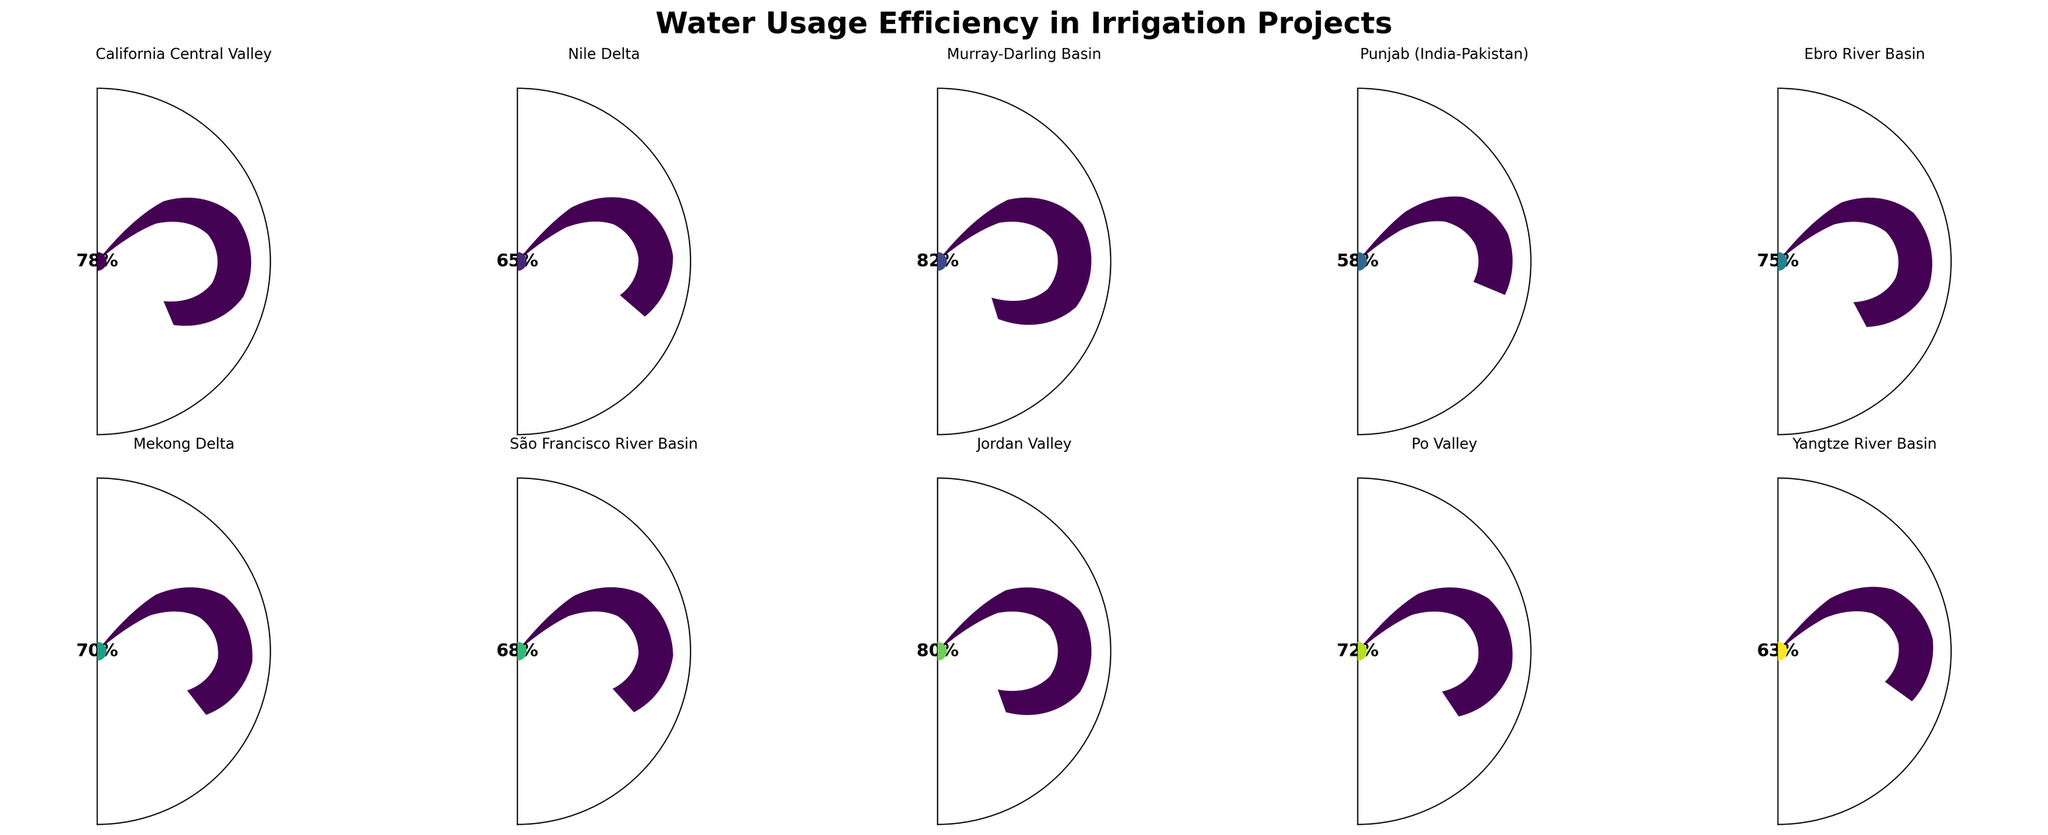Which region has the highest water usage efficiency? First, identify the gauge chart with the highest efficiency percentage. The Murray-Darling Basin has an efficiency of 82%, which is the highest among the regions listed.
Answer: Murray-Darling Basin Which region has the lowest water usage efficiency? Identify the gauge chart with the lowest efficiency percentage. Punjab (India-Pakistan) shows an efficiency of 58%, making it the lowest among the regions listed.
Answer: Punjab (India-Pakistan) What is the average water usage efficiency across all regions? Add up the water usage efficiencies for all regions (78 + 65 + 82 + 58 + 75 + 70 + 68 + 80 + 72 + 63 = 711) and divide by the number of regions (10) to get the average (711 / 10).
Answer: 71.1% Which regions have an efficiency greater than 75%? Identify the gauge charts with efficiency percentages greater than 75%. The regions are California Central Valley (78%), Murray-Darling Basin (82%), and Jordan Valley (80%).
Answer: California Central Valley, Murray-Darling Basin, Jordan Valley How many regions have an efficiency percentage between 60% and 70%? Count the number of gauge charts with efficiency percentages in the specified range. Examples include Nile Delta (65%), Mekong Delta (70%), and São Francisco River Basin (68%). The total is 3 regions.
Answer: 3 Is the water usage efficiency of Ebro River Basin greater than Yangtze River Basin? Compare the efficiency percentages of Ebro River Basin (75%) and Yangtze River Basin (63%) from the gauge charts. Since 75% is greater than 63%, the efficiency of Ebro River Basin is higher.
Answer: Yes Which two regions have the most similar water usage efficiencies? Observe the gauge charts to find the two regions with the closest efficiency percentages. The Po Valley (72%) and Mekong Delta (70%) have values that are only 2 percentage points apart.
Answer: Po Valley and Mekong Delta What is the median water usage efficiency of the listed regions? First, arrange the efficiencies in ascending order: 58, 63, 65, 68, 70, 72, 75, 78, 80, 82. With 10 values, the median is the average of the 5th and 6th values: (70 + 72) / 2.
Answer: 71% Does any region have exactly 70% efficiency? Look for regions with a gauge chart indicating exactly 70% efficiency. The Mekong Delta has an efficiency of 70%.
Answer: Yes Which regions have a water usage efficiency below the average? Compare each region's efficiency to the calculated average (71.1%). The regions below this average are Nile Delta (65%), Punjab (India-Pakistan) (58%), São Francisco River Basin (68%), and Yangtze River Basin (63%).
Answer: Nile Delta, Punjab (India-Pakistan), São Francisco River Basin, Yangtze River Basin 